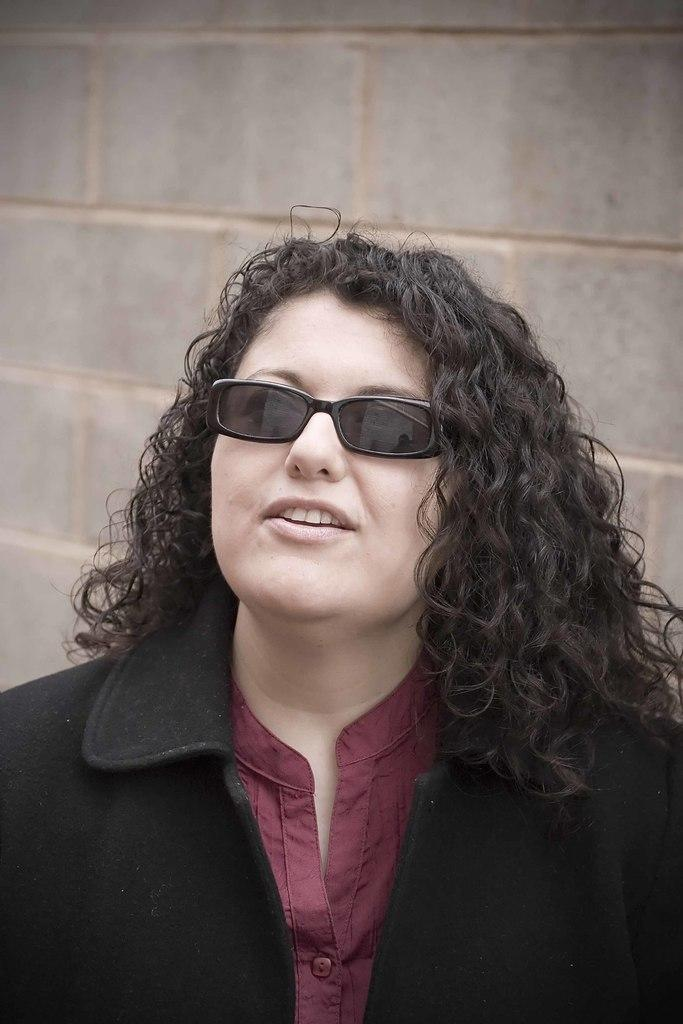Who is present in the image? There is a woman in the image. What is the woman wearing on her face? The woman is wearing spectacles. What is the woman's facial expression in the image? The woman is smiling. What can be seen in the background of the image? There is a wall visible in the background of the image. What type of soap is the woman holding in the image? There is no soap present in the image; the woman is not holding anything. How many forks can be seen in the image? There are no forks present in the image. 